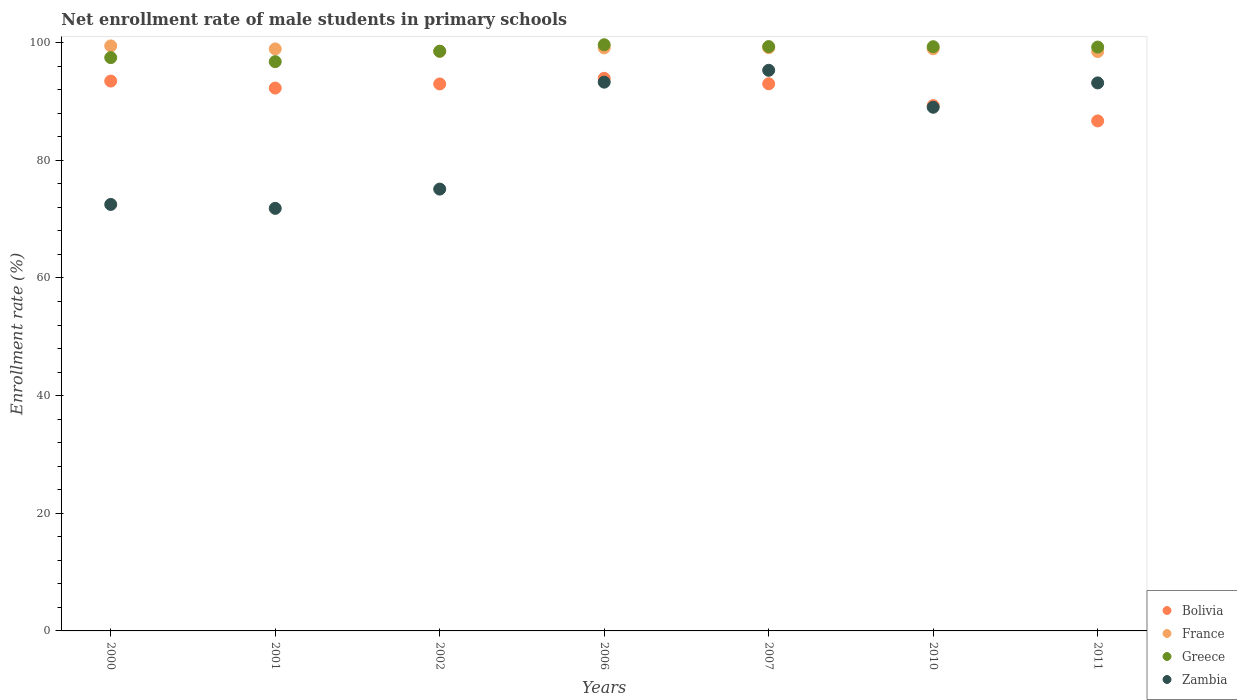How many different coloured dotlines are there?
Make the answer very short. 4. Is the number of dotlines equal to the number of legend labels?
Your response must be concise. Yes. What is the net enrollment rate of male students in primary schools in France in 2006?
Your response must be concise. 99.11. Across all years, what is the maximum net enrollment rate of male students in primary schools in France?
Offer a terse response. 99.45. Across all years, what is the minimum net enrollment rate of male students in primary schools in France?
Your response must be concise. 98.48. In which year was the net enrollment rate of male students in primary schools in Bolivia maximum?
Provide a succinct answer. 2006. What is the total net enrollment rate of male students in primary schools in Zambia in the graph?
Your response must be concise. 590.21. What is the difference between the net enrollment rate of male students in primary schools in Greece in 2000 and that in 2006?
Ensure brevity in your answer.  -2.19. What is the difference between the net enrollment rate of male students in primary schools in Bolivia in 2011 and the net enrollment rate of male students in primary schools in Greece in 2007?
Give a very brief answer. -12.64. What is the average net enrollment rate of male students in primary schools in Bolivia per year?
Your response must be concise. 91.67. In the year 2002, what is the difference between the net enrollment rate of male students in primary schools in Zambia and net enrollment rate of male students in primary schools in Greece?
Your response must be concise. -23.43. What is the ratio of the net enrollment rate of male students in primary schools in France in 2002 to that in 2007?
Offer a very short reply. 0.99. Is the difference between the net enrollment rate of male students in primary schools in Zambia in 2002 and 2006 greater than the difference between the net enrollment rate of male students in primary schools in Greece in 2002 and 2006?
Provide a succinct answer. No. What is the difference between the highest and the second highest net enrollment rate of male students in primary schools in Greece?
Your response must be concise. 0.31. What is the difference between the highest and the lowest net enrollment rate of male students in primary schools in France?
Your answer should be very brief. 0.97. Is the sum of the net enrollment rate of male students in primary schools in Bolivia in 2000 and 2010 greater than the maximum net enrollment rate of male students in primary schools in Greece across all years?
Ensure brevity in your answer.  Yes. Is it the case that in every year, the sum of the net enrollment rate of male students in primary schools in France and net enrollment rate of male students in primary schools in Greece  is greater than the net enrollment rate of male students in primary schools in Bolivia?
Your answer should be very brief. Yes. Does the net enrollment rate of male students in primary schools in France monotonically increase over the years?
Your answer should be compact. No. Is the net enrollment rate of male students in primary schools in France strictly less than the net enrollment rate of male students in primary schools in Zambia over the years?
Your response must be concise. No. How many dotlines are there?
Your answer should be compact. 4. What is the difference between two consecutive major ticks on the Y-axis?
Your answer should be very brief. 20. Are the values on the major ticks of Y-axis written in scientific E-notation?
Your answer should be very brief. No. Does the graph contain any zero values?
Offer a terse response. No. Does the graph contain grids?
Provide a short and direct response. No. Where does the legend appear in the graph?
Offer a terse response. Bottom right. How many legend labels are there?
Make the answer very short. 4. What is the title of the graph?
Offer a terse response. Net enrollment rate of male students in primary schools. Does "Grenada" appear as one of the legend labels in the graph?
Offer a terse response. No. What is the label or title of the Y-axis?
Make the answer very short. Enrollment rate (%). What is the Enrollment rate (%) in Bolivia in 2000?
Offer a very short reply. 93.47. What is the Enrollment rate (%) of France in 2000?
Keep it short and to the point. 99.45. What is the Enrollment rate (%) in Greece in 2000?
Offer a terse response. 97.46. What is the Enrollment rate (%) of Zambia in 2000?
Offer a very short reply. 72.5. What is the Enrollment rate (%) in Bolivia in 2001?
Your answer should be very brief. 92.28. What is the Enrollment rate (%) in France in 2001?
Offer a terse response. 98.94. What is the Enrollment rate (%) in Greece in 2001?
Keep it short and to the point. 96.77. What is the Enrollment rate (%) in Zambia in 2001?
Offer a terse response. 71.83. What is the Enrollment rate (%) in Bolivia in 2002?
Your response must be concise. 92.98. What is the Enrollment rate (%) of France in 2002?
Ensure brevity in your answer.  98.53. What is the Enrollment rate (%) of Greece in 2002?
Provide a short and direct response. 98.54. What is the Enrollment rate (%) in Zambia in 2002?
Your response must be concise. 75.11. What is the Enrollment rate (%) in Bolivia in 2006?
Offer a terse response. 93.94. What is the Enrollment rate (%) in France in 2006?
Keep it short and to the point. 99.11. What is the Enrollment rate (%) in Greece in 2006?
Give a very brief answer. 99.64. What is the Enrollment rate (%) of Zambia in 2006?
Your response must be concise. 93.29. What is the Enrollment rate (%) of Bolivia in 2007?
Offer a very short reply. 93.01. What is the Enrollment rate (%) of France in 2007?
Provide a short and direct response. 99.14. What is the Enrollment rate (%) in Greece in 2007?
Your answer should be compact. 99.33. What is the Enrollment rate (%) in Zambia in 2007?
Your response must be concise. 95.3. What is the Enrollment rate (%) in Bolivia in 2010?
Your answer should be compact. 89.3. What is the Enrollment rate (%) in France in 2010?
Ensure brevity in your answer.  98.96. What is the Enrollment rate (%) of Greece in 2010?
Make the answer very short. 99.31. What is the Enrollment rate (%) of Zambia in 2010?
Offer a very short reply. 89.02. What is the Enrollment rate (%) in Bolivia in 2011?
Keep it short and to the point. 86.7. What is the Enrollment rate (%) of France in 2011?
Make the answer very short. 98.48. What is the Enrollment rate (%) of Greece in 2011?
Make the answer very short. 99.25. What is the Enrollment rate (%) of Zambia in 2011?
Give a very brief answer. 93.16. Across all years, what is the maximum Enrollment rate (%) in Bolivia?
Your answer should be very brief. 93.94. Across all years, what is the maximum Enrollment rate (%) in France?
Your response must be concise. 99.45. Across all years, what is the maximum Enrollment rate (%) of Greece?
Offer a very short reply. 99.64. Across all years, what is the maximum Enrollment rate (%) of Zambia?
Offer a very short reply. 95.3. Across all years, what is the minimum Enrollment rate (%) in Bolivia?
Make the answer very short. 86.7. Across all years, what is the minimum Enrollment rate (%) of France?
Ensure brevity in your answer.  98.48. Across all years, what is the minimum Enrollment rate (%) in Greece?
Your answer should be compact. 96.77. Across all years, what is the minimum Enrollment rate (%) of Zambia?
Keep it short and to the point. 71.83. What is the total Enrollment rate (%) in Bolivia in the graph?
Your response must be concise. 641.67. What is the total Enrollment rate (%) of France in the graph?
Give a very brief answer. 692.61. What is the total Enrollment rate (%) of Greece in the graph?
Give a very brief answer. 690.31. What is the total Enrollment rate (%) in Zambia in the graph?
Provide a short and direct response. 590.21. What is the difference between the Enrollment rate (%) in Bolivia in 2000 and that in 2001?
Your answer should be very brief. 1.19. What is the difference between the Enrollment rate (%) in France in 2000 and that in 2001?
Give a very brief answer. 0.51. What is the difference between the Enrollment rate (%) in Greece in 2000 and that in 2001?
Provide a succinct answer. 0.69. What is the difference between the Enrollment rate (%) of Zambia in 2000 and that in 2001?
Offer a very short reply. 0.67. What is the difference between the Enrollment rate (%) in Bolivia in 2000 and that in 2002?
Ensure brevity in your answer.  0.49. What is the difference between the Enrollment rate (%) of France in 2000 and that in 2002?
Provide a short and direct response. 0.93. What is the difference between the Enrollment rate (%) in Greece in 2000 and that in 2002?
Keep it short and to the point. -1.09. What is the difference between the Enrollment rate (%) of Zambia in 2000 and that in 2002?
Your response must be concise. -2.61. What is the difference between the Enrollment rate (%) of Bolivia in 2000 and that in 2006?
Keep it short and to the point. -0.47. What is the difference between the Enrollment rate (%) in France in 2000 and that in 2006?
Ensure brevity in your answer.  0.34. What is the difference between the Enrollment rate (%) in Greece in 2000 and that in 2006?
Your answer should be compact. -2.19. What is the difference between the Enrollment rate (%) of Zambia in 2000 and that in 2006?
Ensure brevity in your answer.  -20.79. What is the difference between the Enrollment rate (%) of Bolivia in 2000 and that in 2007?
Give a very brief answer. 0.46. What is the difference between the Enrollment rate (%) in France in 2000 and that in 2007?
Your response must be concise. 0.31. What is the difference between the Enrollment rate (%) of Greece in 2000 and that in 2007?
Provide a succinct answer. -1.88. What is the difference between the Enrollment rate (%) in Zambia in 2000 and that in 2007?
Ensure brevity in your answer.  -22.8. What is the difference between the Enrollment rate (%) in Bolivia in 2000 and that in 2010?
Provide a succinct answer. 4.17. What is the difference between the Enrollment rate (%) in France in 2000 and that in 2010?
Provide a short and direct response. 0.5. What is the difference between the Enrollment rate (%) of Greece in 2000 and that in 2010?
Your response must be concise. -1.85. What is the difference between the Enrollment rate (%) in Zambia in 2000 and that in 2010?
Your answer should be compact. -16.52. What is the difference between the Enrollment rate (%) in Bolivia in 2000 and that in 2011?
Make the answer very short. 6.77. What is the difference between the Enrollment rate (%) of France in 2000 and that in 2011?
Make the answer very short. 0.97. What is the difference between the Enrollment rate (%) in Greece in 2000 and that in 2011?
Ensure brevity in your answer.  -1.79. What is the difference between the Enrollment rate (%) in Zambia in 2000 and that in 2011?
Ensure brevity in your answer.  -20.66. What is the difference between the Enrollment rate (%) of Bolivia in 2001 and that in 2002?
Make the answer very short. -0.7. What is the difference between the Enrollment rate (%) in France in 2001 and that in 2002?
Offer a terse response. 0.41. What is the difference between the Enrollment rate (%) of Greece in 2001 and that in 2002?
Your response must be concise. -1.77. What is the difference between the Enrollment rate (%) in Zambia in 2001 and that in 2002?
Your answer should be very brief. -3.28. What is the difference between the Enrollment rate (%) in Bolivia in 2001 and that in 2006?
Give a very brief answer. -1.65. What is the difference between the Enrollment rate (%) of France in 2001 and that in 2006?
Provide a succinct answer. -0.17. What is the difference between the Enrollment rate (%) of Greece in 2001 and that in 2006?
Make the answer very short. -2.87. What is the difference between the Enrollment rate (%) in Zambia in 2001 and that in 2006?
Keep it short and to the point. -21.45. What is the difference between the Enrollment rate (%) in Bolivia in 2001 and that in 2007?
Your answer should be very brief. -0.72. What is the difference between the Enrollment rate (%) of France in 2001 and that in 2007?
Ensure brevity in your answer.  -0.2. What is the difference between the Enrollment rate (%) of Greece in 2001 and that in 2007?
Ensure brevity in your answer.  -2.56. What is the difference between the Enrollment rate (%) in Zambia in 2001 and that in 2007?
Make the answer very short. -23.47. What is the difference between the Enrollment rate (%) of Bolivia in 2001 and that in 2010?
Offer a very short reply. 2.98. What is the difference between the Enrollment rate (%) of France in 2001 and that in 2010?
Your answer should be compact. -0.02. What is the difference between the Enrollment rate (%) in Greece in 2001 and that in 2010?
Your answer should be very brief. -2.54. What is the difference between the Enrollment rate (%) of Zambia in 2001 and that in 2010?
Offer a very short reply. -17.19. What is the difference between the Enrollment rate (%) in Bolivia in 2001 and that in 2011?
Provide a succinct answer. 5.58. What is the difference between the Enrollment rate (%) of France in 2001 and that in 2011?
Your response must be concise. 0.46. What is the difference between the Enrollment rate (%) of Greece in 2001 and that in 2011?
Make the answer very short. -2.48. What is the difference between the Enrollment rate (%) of Zambia in 2001 and that in 2011?
Your answer should be compact. -21.32. What is the difference between the Enrollment rate (%) of Bolivia in 2002 and that in 2006?
Provide a succinct answer. -0.95. What is the difference between the Enrollment rate (%) of France in 2002 and that in 2006?
Provide a short and direct response. -0.58. What is the difference between the Enrollment rate (%) in Greece in 2002 and that in 2006?
Provide a short and direct response. -1.1. What is the difference between the Enrollment rate (%) of Zambia in 2002 and that in 2006?
Ensure brevity in your answer.  -18.18. What is the difference between the Enrollment rate (%) of Bolivia in 2002 and that in 2007?
Keep it short and to the point. -0.02. What is the difference between the Enrollment rate (%) of France in 2002 and that in 2007?
Your answer should be very brief. -0.61. What is the difference between the Enrollment rate (%) in Greece in 2002 and that in 2007?
Offer a terse response. -0.79. What is the difference between the Enrollment rate (%) of Zambia in 2002 and that in 2007?
Your answer should be compact. -20.19. What is the difference between the Enrollment rate (%) of Bolivia in 2002 and that in 2010?
Your response must be concise. 3.68. What is the difference between the Enrollment rate (%) in France in 2002 and that in 2010?
Your answer should be very brief. -0.43. What is the difference between the Enrollment rate (%) of Greece in 2002 and that in 2010?
Your answer should be compact. -0.77. What is the difference between the Enrollment rate (%) of Zambia in 2002 and that in 2010?
Your answer should be compact. -13.91. What is the difference between the Enrollment rate (%) in Bolivia in 2002 and that in 2011?
Give a very brief answer. 6.28. What is the difference between the Enrollment rate (%) of France in 2002 and that in 2011?
Provide a succinct answer. 0.04. What is the difference between the Enrollment rate (%) of Greece in 2002 and that in 2011?
Your response must be concise. -0.71. What is the difference between the Enrollment rate (%) in Zambia in 2002 and that in 2011?
Make the answer very short. -18.05. What is the difference between the Enrollment rate (%) of Bolivia in 2006 and that in 2007?
Your answer should be very brief. 0.93. What is the difference between the Enrollment rate (%) in France in 2006 and that in 2007?
Provide a succinct answer. -0.03. What is the difference between the Enrollment rate (%) of Greece in 2006 and that in 2007?
Give a very brief answer. 0.31. What is the difference between the Enrollment rate (%) in Zambia in 2006 and that in 2007?
Your response must be concise. -2.01. What is the difference between the Enrollment rate (%) of Bolivia in 2006 and that in 2010?
Give a very brief answer. 4.63. What is the difference between the Enrollment rate (%) in France in 2006 and that in 2010?
Ensure brevity in your answer.  0.15. What is the difference between the Enrollment rate (%) of Greece in 2006 and that in 2010?
Provide a succinct answer. 0.33. What is the difference between the Enrollment rate (%) in Zambia in 2006 and that in 2010?
Provide a short and direct response. 4.27. What is the difference between the Enrollment rate (%) in Bolivia in 2006 and that in 2011?
Your answer should be compact. 7.24. What is the difference between the Enrollment rate (%) of France in 2006 and that in 2011?
Offer a terse response. 0.63. What is the difference between the Enrollment rate (%) in Greece in 2006 and that in 2011?
Offer a very short reply. 0.39. What is the difference between the Enrollment rate (%) of Zambia in 2006 and that in 2011?
Provide a short and direct response. 0.13. What is the difference between the Enrollment rate (%) of Bolivia in 2007 and that in 2010?
Provide a short and direct response. 3.7. What is the difference between the Enrollment rate (%) of France in 2007 and that in 2010?
Your response must be concise. 0.18. What is the difference between the Enrollment rate (%) in Greece in 2007 and that in 2010?
Your response must be concise. 0.02. What is the difference between the Enrollment rate (%) of Zambia in 2007 and that in 2010?
Provide a succinct answer. 6.28. What is the difference between the Enrollment rate (%) of Bolivia in 2007 and that in 2011?
Your answer should be compact. 6.31. What is the difference between the Enrollment rate (%) in France in 2007 and that in 2011?
Provide a succinct answer. 0.65. What is the difference between the Enrollment rate (%) in Greece in 2007 and that in 2011?
Ensure brevity in your answer.  0.08. What is the difference between the Enrollment rate (%) of Zambia in 2007 and that in 2011?
Make the answer very short. 2.14. What is the difference between the Enrollment rate (%) of Bolivia in 2010 and that in 2011?
Ensure brevity in your answer.  2.6. What is the difference between the Enrollment rate (%) of France in 2010 and that in 2011?
Offer a very short reply. 0.47. What is the difference between the Enrollment rate (%) of Greece in 2010 and that in 2011?
Make the answer very short. 0.06. What is the difference between the Enrollment rate (%) in Zambia in 2010 and that in 2011?
Your answer should be very brief. -4.14. What is the difference between the Enrollment rate (%) of Bolivia in 2000 and the Enrollment rate (%) of France in 2001?
Provide a succinct answer. -5.47. What is the difference between the Enrollment rate (%) of Bolivia in 2000 and the Enrollment rate (%) of Greece in 2001?
Keep it short and to the point. -3.3. What is the difference between the Enrollment rate (%) of Bolivia in 2000 and the Enrollment rate (%) of Zambia in 2001?
Ensure brevity in your answer.  21.64. What is the difference between the Enrollment rate (%) of France in 2000 and the Enrollment rate (%) of Greece in 2001?
Offer a very short reply. 2.68. What is the difference between the Enrollment rate (%) of France in 2000 and the Enrollment rate (%) of Zambia in 2001?
Your answer should be very brief. 27.62. What is the difference between the Enrollment rate (%) in Greece in 2000 and the Enrollment rate (%) in Zambia in 2001?
Your response must be concise. 25.62. What is the difference between the Enrollment rate (%) in Bolivia in 2000 and the Enrollment rate (%) in France in 2002?
Give a very brief answer. -5.06. What is the difference between the Enrollment rate (%) in Bolivia in 2000 and the Enrollment rate (%) in Greece in 2002?
Your response must be concise. -5.07. What is the difference between the Enrollment rate (%) of Bolivia in 2000 and the Enrollment rate (%) of Zambia in 2002?
Offer a very short reply. 18.36. What is the difference between the Enrollment rate (%) in France in 2000 and the Enrollment rate (%) in Greece in 2002?
Make the answer very short. 0.91. What is the difference between the Enrollment rate (%) of France in 2000 and the Enrollment rate (%) of Zambia in 2002?
Your answer should be compact. 24.34. What is the difference between the Enrollment rate (%) in Greece in 2000 and the Enrollment rate (%) in Zambia in 2002?
Your answer should be compact. 22.35. What is the difference between the Enrollment rate (%) in Bolivia in 2000 and the Enrollment rate (%) in France in 2006?
Provide a succinct answer. -5.64. What is the difference between the Enrollment rate (%) in Bolivia in 2000 and the Enrollment rate (%) in Greece in 2006?
Offer a very short reply. -6.17. What is the difference between the Enrollment rate (%) in Bolivia in 2000 and the Enrollment rate (%) in Zambia in 2006?
Your response must be concise. 0.18. What is the difference between the Enrollment rate (%) of France in 2000 and the Enrollment rate (%) of Greece in 2006?
Give a very brief answer. -0.19. What is the difference between the Enrollment rate (%) of France in 2000 and the Enrollment rate (%) of Zambia in 2006?
Give a very brief answer. 6.17. What is the difference between the Enrollment rate (%) of Greece in 2000 and the Enrollment rate (%) of Zambia in 2006?
Your answer should be compact. 4.17. What is the difference between the Enrollment rate (%) of Bolivia in 2000 and the Enrollment rate (%) of France in 2007?
Your answer should be very brief. -5.67. What is the difference between the Enrollment rate (%) in Bolivia in 2000 and the Enrollment rate (%) in Greece in 2007?
Provide a short and direct response. -5.86. What is the difference between the Enrollment rate (%) in Bolivia in 2000 and the Enrollment rate (%) in Zambia in 2007?
Offer a terse response. -1.83. What is the difference between the Enrollment rate (%) in France in 2000 and the Enrollment rate (%) in Greece in 2007?
Your response must be concise. 0.12. What is the difference between the Enrollment rate (%) of France in 2000 and the Enrollment rate (%) of Zambia in 2007?
Ensure brevity in your answer.  4.15. What is the difference between the Enrollment rate (%) in Greece in 2000 and the Enrollment rate (%) in Zambia in 2007?
Your answer should be compact. 2.15. What is the difference between the Enrollment rate (%) of Bolivia in 2000 and the Enrollment rate (%) of France in 2010?
Your answer should be very brief. -5.49. What is the difference between the Enrollment rate (%) of Bolivia in 2000 and the Enrollment rate (%) of Greece in 2010?
Offer a terse response. -5.84. What is the difference between the Enrollment rate (%) of Bolivia in 2000 and the Enrollment rate (%) of Zambia in 2010?
Your answer should be compact. 4.45. What is the difference between the Enrollment rate (%) in France in 2000 and the Enrollment rate (%) in Greece in 2010?
Offer a terse response. 0.14. What is the difference between the Enrollment rate (%) in France in 2000 and the Enrollment rate (%) in Zambia in 2010?
Ensure brevity in your answer.  10.43. What is the difference between the Enrollment rate (%) in Greece in 2000 and the Enrollment rate (%) in Zambia in 2010?
Your answer should be very brief. 8.44. What is the difference between the Enrollment rate (%) in Bolivia in 2000 and the Enrollment rate (%) in France in 2011?
Give a very brief answer. -5.01. What is the difference between the Enrollment rate (%) in Bolivia in 2000 and the Enrollment rate (%) in Greece in 2011?
Provide a short and direct response. -5.78. What is the difference between the Enrollment rate (%) of Bolivia in 2000 and the Enrollment rate (%) of Zambia in 2011?
Give a very brief answer. 0.31. What is the difference between the Enrollment rate (%) of France in 2000 and the Enrollment rate (%) of Greece in 2011?
Ensure brevity in your answer.  0.2. What is the difference between the Enrollment rate (%) in France in 2000 and the Enrollment rate (%) in Zambia in 2011?
Your answer should be compact. 6.3. What is the difference between the Enrollment rate (%) in Greece in 2000 and the Enrollment rate (%) in Zambia in 2011?
Ensure brevity in your answer.  4.3. What is the difference between the Enrollment rate (%) of Bolivia in 2001 and the Enrollment rate (%) of France in 2002?
Offer a terse response. -6.24. What is the difference between the Enrollment rate (%) in Bolivia in 2001 and the Enrollment rate (%) in Greece in 2002?
Ensure brevity in your answer.  -6.26. What is the difference between the Enrollment rate (%) of Bolivia in 2001 and the Enrollment rate (%) of Zambia in 2002?
Make the answer very short. 17.17. What is the difference between the Enrollment rate (%) in France in 2001 and the Enrollment rate (%) in Greece in 2002?
Provide a short and direct response. 0.4. What is the difference between the Enrollment rate (%) of France in 2001 and the Enrollment rate (%) of Zambia in 2002?
Provide a succinct answer. 23.83. What is the difference between the Enrollment rate (%) of Greece in 2001 and the Enrollment rate (%) of Zambia in 2002?
Your answer should be compact. 21.66. What is the difference between the Enrollment rate (%) in Bolivia in 2001 and the Enrollment rate (%) in France in 2006?
Ensure brevity in your answer.  -6.83. What is the difference between the Enrollment rate (%) of Bolivia in 2001 and the Enrollment rate (%) of Greece in 2006?
Provide a succinct answer. -7.36. What is the difference between the Enrollment rate (%) in Bolivia in 2001 and the Enrollment rate (%) in Zambia in 2006?
Ensure brevity in your answer.  -1. What is the difference between the Enrollment rate (%) in France in 2001 and the Enrollment rate (%) in Greece in 2006?
Offer a terse response. -0.7. What is the difference between the Enrollment rate (%) in France in 2001 and the Enrollment rate (%) in Zambia in 2006?
Provide a short and direct response. 5.65. What is the difference between the Enrollment rate (%) of Greece in 2001 and the Enrollment rate (%) of Zambia in 2006?
Your answer should be very brief. 3.48. What is the difference between the Enrollment rate (%) in Bolivia in 2001 and the Enrollment rate (%) in France in 2007?
Keep it short and to the point. -6.86. What is the difference between the Enrollment rate (%) of Bolivia in 2001 and the Enrollment rate (%) of Greece in 2007?
Your answer should be very brief. -7.05. What is the difference between the Enrollment rate (%) in Bolivia in 2001 and the Enrollment rate (%) in Zambia in 2007?
Your response must be concise. -3.02. What is the difference between the Enrollment rate (%) in France in 2001 and the Enrollment rate (%) in Greece in 2007?
Offer a very short reply. -0.39. What is the difference between the Enrollment rate (%) of France in 2001 and the Enrollment rate (%) of Zambia in 2007?
Keep it short and to the point. 3.64. What is the difference between the Enrollment rate (%) in Greece in 2001 and the Enrollment rate (%) in Zambia in 2007?
Give a very brief answer. 1.47. What is the difference between the Enrollment rate (%) in Bolivia in 2001 and the Enrollment rate (%) in France in 2010?
Your response must be concise. -6.67. What is the difference between the Enrollment rate (%) of Bolivia in 2001 and the Enrollment rate (%) of Greece in 2010?
Provide a short and direct response. -7.03. What is the difference between the Enrollment rate (%) of Bolivia in 2001 and the Enrollment rate (%) of Zambia in 2010?
Offer a very short reply. 3.26. What is the difference between the Enrollment rate (%) of France in 2001 and the Enrollment rate (%) of Greece in 2010?
Provide a short and direct response. -0.37. What is the difference between the Enrollment rate (%) in France in 2001 and the Enrollment rate (%) in Zambia in 2010?
Your response must be concise. 9.92. What is the difference between the Enrollment rate (%) of Greece in 2001 and the Enrollment rate (%) of Zambia in 2010?
Provide a succinct answer. 7.75. What is the difference between the Enrollment rate (%) of Bolivia in 2001 and the Enrollment rate (%) of France in 2011?
Your response must be concise. -6.2. What is the difference between the Enrollment rate (%) of Bolivia in 2001 and the Enrollment rate (%) of Greece in 2011?
Provide a succinct answer. -6.97. What is the difference between the Enrollment rate (%) of Bolivia in 2001 and the Enrollment rate (%) of Zambia in 2011?
Keep it short and to the point. -0.87. What is the difference between the Enrollment rate (%) in France in 2001 and the Enrollment rate (%) in Greece in 2011?
Provide a succinct answer. -0.31. What is the difference between the Enrollment rate (%) in France in 2001 and the Enrollment rate (%) in Zambia in 2011?
Make the answer very short. 5.78. What is the difference between the Enrollment rate (%) of Greece in 2001 and the Enrollment rate (%) of Zambia in 2011?
Ensure brevity in your answer.  3.61. What is the difference between the Enrollment rate (%) in Bolivia in 2002 and the Enrollment rate (%) in France in 2006?
Make the answer very short. -6.13. What is the difference between the Enrollment rate (%) in Bolivia in 2002 and the Enrollment rate (%) in Greece in 2006?
Make the answer very short. -6.66. What is the difference between the Enrollment rate (%) in Bolivia in 2002 and the Enrollment rate (%) in Zambia in 2006?
Keep it short and to the point. -0.31. What is the difference between the Enrollment rate (%) of France in 2002 and the Enrollment rate (%) of Greece in 2006?
Offer a terse response. -1.12. What is the difference between the Enrollment rate (%) of France in 2002 and the Enrollment rate (%) of Zambia in 2006?
Provide a succinct answer. 5.24. What is the difference between the Enrollment rate (%) in Greece in 2002 and the Enrollment rate (%) in Zambia in 2006?
Make the answer very short. 5.26. What is the difference between the Enrollment rate (%) in Bolivia in 2002 and the Enrollment rate (%) in France in 2007?
Keep it short and to the point. -6.16. What is the difference between the Enrollment rate (%) in Bolivia in 2002 and the Enrollment rate (%) in Greece in 2007?
Keep it short and to the point. -6.35. What is the difference between the Enrollment rate (%) in Bolivia in 2002 and the Enrollment rate (%) in Zambia in 2007?
Offer a very short reply. -2.32. What is the difference between the Enrollment rate (%) in France in 2002 and the Enrollment rate (%) in Greece in 2007?
Provide a succinct answer. -0.81. What is the difference between the Enrollment rate (%) in France in 2002 and the Enrollment rate (%) in Zambia in 2007?
Ensure brevity in your answer.  3.22. What is the difference between the Enrollment rate (%) in Greece in 2002 and the Enrollment rate (%) in Zambia in 2007?
Keep it short and to the point. 3.24. What is the difference between the Enrollment rate (%) in Bolivia in 2002 and the Enrollment rate (%) in France in 2010?
Provide a succinct answer. -5.98. What is the difference between the Enrollment rate (%) of Bolivia in 2002 and the Enrollment rate (%) of Greece in 2010?
Offer a very short reply. -6.33. What is the difference between the Enrollment rate (%) of Bolivia in 2002 and the Enrollment rate (%) of Zambia in 2010?
Offer a very short reply. 3.96. What is the difference between the Enrollment rate (%) of France in 2002 and the Enrollment rate (%) of Greece in 2010?
Your answer should be very brief. -0.79. What is the difference between the Enrollment rate (%) in France in 2002 and the Enrollment rate (%) in Zambia in 2010?
Offer a very short reply. 9.51. What is the difference between the Enrollment rate (%) in Greece in 2002 and the Enrollment rate (%) in Zambia in 2010?
Offer a very short reply. 9.52. What is the difference between the Enrollment rate (%) of Bolivia in 2002 and the Enrollment rate (%) of France in 2011?
Keep it short and to the point. -5.5. What is the difference between the Enrollment rate (%) in Bolivia in 2002 and the Enrollment rate (%) in Greece in 2011?
Offer a very short reply. -6.27. What is the difference between the Enrollment rate (%) of Bolivia in 2002 and the Enrollment rate (%) of Zambia in 2011?
Your response must be concise. -0.18. What is the difference between the Enrollment rate (%) in France in 2002 and the Enrollment rate (%) in Greece in 2011?
Make the answer very short. -0.72. What is the difference between the Enrollment rate (%) in France in 2002 and the Enrollment rate (%) in Zambia in 2011?
Your answer should be very brief. 5.37. What is the difference between the Enrollment rate (%) in Greece in 2002 and the Enrollment rate (%) in Zambia in 2011?
Ensure brevity in your answer.  5.38. What is the difference between the Enrollment rate (%) of Bolivia in 2006 and the Enrollment rate (%) of France in 2007?
Your answer should be very brief. -5.2. What is the difference between the Enrollment rate (%) of Bolivia in 2006 and the Enrollment rate (%) of Greece in 2007?
Provide a succinct answer. -5.4. What is the difference between the Enrollment rate (%) in Bolivia in 2006 and the Enrollment rate (%) in Zambia in 2007?
Offer a terse response. -1.37. What is the difference between the Enrollment rate (%) of France in 2006 and the Enrollment rate (%) of Greece in 2007?
Your response must be concise. -0.23. What is the difference between the Enrollment rate (%) in France in 2006 and the Enrollment rate (%) in Zambia in 2007?
Make the answer very short. 3.81. What is the difference between the Enrollment rate (%) of Greece in 2006 and the Enrollment rate (%) of Zambia in 2007?
Offer a very short reply. 4.34. What is the difference between the Enrollment rate (%) of Bolivia in 2006 and the Enrollment rate (%) of France in 2010?
Offer a terse response. -5.02. What is the difference between the Enrollment rate (%) of Bolivia in 2006 and the Enrollment rate (%) of Greece in 2010?
Offer a very short reply. -5.38. What is the difference between the Enrollment rate (%) in Bolivia in 2006 and the Enrollment rate (%) in Zambia in 2010?
Offer a very short reply. 4.92. What is the difference between the Enrollment rate (%) of France in 2006 and the Enrollment rate (%) of Greece in 2010?
Your answer should be very brief. -0.2. What is the difference between the Enrollment rate (%) in France in 2006 and the Enrollment rate (%) in Zambia in 2010?
Ensure brevity in your answer.  10.09. What is the difference between the Enrollment rate (%) in Greece in 2006 and the Enrollment rate (%) in Zambia in 2010?
Offer a terse response. 10.63. What is the difference between the Enrollment rate (%) in Bolivia in 2006 and the Enrollment rate (%) in France in 2011?
Your response must be concise. -4.55. What is the difference between the Enrollment rate (%) in Bolivia in 2006 and the Enrollment rate (%) in Greece in 2011?
Your response must be concise. -5.31. What is the difference between the Enrollment rate (%) of Bolivia in 2006 and the Enrollment rate (%) of Zambia in 2011?
Offer a terse response. 0.78. What is the difference between the Enrollment rate (%) in France in 2006 and the Enrollment rate (%) in Greece in 2011?
Your answer should be very brief. -0.14. What is the difference between the Enrollment rate (%) of France in 2006 and the Enrollment rate (%) of Zambia in 2011?
Provide a short and direct response. 5.95. What is the difference between the Enrollment rate (%) of Greece in 2006 and the Enrollment rate (%) of Zambia in 2011?
Make the answer very short. 6.49. What is the difference between the Enrollment rate (%) in Bolivia in 2007 and the Enrollment rate (%) in France in 2010?
Your response must be concise. -5.95. What is the difference between the Enrollment rate (%) in Bolivia in 2007 and the Enrollment rate (%) in Greece in 2010?
Offer a very short reply. -6.31. What is the difference between the Enrollment rate (%) of Bolivia in 2007 and the Enrollment rate (%) of Zambia in 2010?
Ensure brevity in your answer.  3.99. What is the difference between the Enrollment rate (%) in France in 2007 and the Enrollment rate (%) in Greece in 2010?
Give a very brief answer. -0.17. What is the difference between the Enrollment rate (%) in France in 2007 and the Enrollment rate (%) in Zambia in 2010?
Your response must be concise. 10.12. What is the difference between the Enrollment rate (%) of Greece in 2007 and the Enrollment rate (%) of Zambia in 2010?
Offer a terse response. 10.32. What is the difference between the Enrollment rate (%) of Bolivia in 2007 and the Enrollment rate (%) of France in 2011?
Your answer should be very brief. -5.48. What is the difference between the Enrollment rate (%) in Bolivia in 2007 and the Enrollment rate (%) in Greece in 2011?
Make the answer very short. -6.24. What is the difference between the Enrollment rate (%) of Bolivia in 2007 and the Enrollment rate (%) of Zambia in 2011?
Ensure brevity in your answer.  -0.15. What is the difference between the Enrollment rate (%) of France in 2007 and the Enrollment rate (%) of Greece in 2011?
Provide a succinct answer. -0.11. What is the difference between the Enrollment rate (%) of France in 2007 and the Enrollment rate (%) of Zambia in 2011?
Offer a very short reply. 5.98. What is the difference between the Enrollment rate (%) in Greece in 2007 and the Enrollment rate (%) in Zambia in 2011?
Your answer should be very brief. 6.18. What is the difference between the Enrollment rate (%) in Bolivia in 2010 and the Enrollment rate (%) in France in 2011?
Your answer should be compact. -9.18. What is the difference between the Enrollment rate (%) of Bolivia in 2010 and the Enrollment rate (%) of Greece in 2011?
Offer a very short reply. -9.95. What is the difference between the Enrollment rate (%) in Bolivia in 2010 and the Enrollment rate (%) in Zambia in 2011?
Provide a succinct answer. -3.86. What is the difference between the Enrollment rate (%) of France in 2010 and the Enrollment rate (%) of Greece in 2011?
Ensure brevity in your answer.  -0.29. What is the difference between the Enrollment rate (%) in France in 2010 and the Enrollment rate (%) in Zambia in 2011?
Your answer should be compact. 5.8. What is the difference between the Enrollment rate (%) of Greece in 2010 and the Enrollment rate (%) of Zambia in 2011?
Offer a terse response. 6.15. What is the average Enrollment rate (%) of Bolivia per year?
Ensure brevity in your answer.  91.67. What is the average Enrollment rate (%) of France per year?
Provide a short and direct response. 98.94. What is the average Enrollment rate (%) in Greece per year?
Provide a succinct answer. 98.62. What is the average Enrollment rate (%) in Zambia per year?
Offer a terse response. 84.32. In the year 2000, what is the difference between the Enrollment rate (%) in Bolivia and Enrollment rate (%) in France?
Your answer should be compact. -5.98. In the year 2000, what is the difference between the Enrollment rate (%) of Bolivia and Enrollment rate (%) of Greece?
Your answer should be compact. -3.99. In the year 2000, what is the difference between the Enrollment rate (%) in Bolivia and Enrollment rate (%) in Zambia?
Give a very brief answer. 20.97. In the year 2000, what is the difference between the Enrollment rate (%) of France and Enrollment rate (%) of Greece?
Your response must be concise. 2. In the year 2000, what is the difference between the Enrollment rate (%) of France and Enrollment rate (%) of Zambia?
Give a very brief answer. 26.95. In the year 2000, what is the difference between the Enrollment rate (%) of Greece and Enrollment rate (%) of Zambia?
Ensure brevity in your answer.  24.96. In the year 2001, what is the difference between the Enrollment rate (%) of Bolivia and Enrollment rate (%) of France?
Give a very brief answer. -6.66. In the year 2001, what is the difference between the Enrollment rate (%) in Bolivia and Enrollment rate (%) in Greece?
Ensure brevity in your answer.  -4.49. In the year 2001, what is the difference between the Enrollment rate (%) of Bolivia and Enrollment rate (%) of Zambia?
Your answer should be compact. 20.45. In the year 2001, what is the difference between the Enrollment rate (%) in France and Enrollment rate (%) in Greece?
Make the answer very short. 2.17. In the year 2001, what is the difference between the Enrollment rate (%) of France and Enrollment rate (%) of Zambia?
Make the answer very short. 27.11. In the year 2001, what is the difference between the Enrollment rate (%) in Greece and Enrollment rate (%) in Zambia?
Your answer should be compact. 24.94. In the year 2002, what is the difference between the Enrollment rate (%) of Bolivia and Enrollment rate (%) of France?
Your response must be concise. -5.54. In the year 2002, what is the difference between the Enrollment rate (%) in Bolivia and Enrollment rate (%) in Greece?
Provide a short and direct response. -5.56. In the year 2002, what is the difference between the Enrollment rate (%) in Bolivia and Enrollment rate (%) in Zambia?
Make the answer very short. 17.87. In the year 2002, what is the difference between the Enrollment rate (%) in France and Enrollment rate (%) in Greece?
Give a very brief answer. -0.02. In the year 2002, what is the difference between the Enrollment rate (%) of France and Enrollment rate (%) of Zambia?
Provide a short and direct response. 23.42. In the year 2002, what is the difference between the Enrollment rate (%) in Greece and Enrollment rate (%) in Zambia?
Keep it short and to the point. 23.43. In the year 2006, what is the difference between the Enrollment rate (%) in Bolivia and Enrollment rate (%) in France?
Ensure brevity in your answer.  -5.17. In the year 2006, what is the difference between the Enrollment rate (%) of Bolivia and Enrollment rate (%) of Greece?
Offer a terse response. -5.71. In the year 2006, what is the difference between the Enrollment rate (%) in Bolivia and Enrollment rate (%) in Zambia?
Give a very brief answer. 0.65. In the year 2006, what is the difference between the Enrollment rate (%) of France and Enrollment rate (%) of Greece?
Give a very brief answer. -0.54. In the year 2006, what is the difference between the Enrollment rate (%) of France and Enrollment rate (%) of Zambia?
Ensure brevity in your answer.  5.82. In the year 2006, what is the difference between the Enrollment rate (%) in Greece and Enrollment rate (%) in Zambia?
Make the answer very short. 6.36. In the year 2007, what is the difference between the Enrollment rate (%) in Bolivia and Enrollment rate (%) in France?
Keep it short and to the point. -6.13. In the year 2007, what is the difference between the Enrollment rate (%) of Bolivia and Enrollment rate (%) of Greece?
Keep it short and to the point. -6.33. In the year 2007, what is the difference between the Enrollment rate (%) of Bolivia and Enrollment rate (%) of Zambia?
Make the answer very short. -2.3. In the year 2007, what is the difference between the Enrollment rate (%) of France and Enrollment rate (%) of Greece?
Your answer should be very brief. -0.2. In the year 2007, what is the difference between the Enrollment rate (%) in France and Enrollment rate (%) in Zambia?
Your response must be concise. 3.84. In the year 2007, what is the difference between the Enrollment rate (%) in Greece and Enrollment rate (%) in Zambia?
Your answer should be compact. 4.03. In the year 2010, what is the difference between the Enrollment rate (%) of Bolivia and Enrollment rate (%) of France?
Provide a short and direct response. -9.66. In the year 2010, what is the difference between the Enrollment rate (%) of Bolivia and Enrollment rate (%) of Greece?
Offer a very short reply. -10.01. In the year 2010, what is the difference between the Enrollment rate (%) of Bolivia and Enrollment rate (%) of Zambia?
Your answer should be compact. 0.28. In the year 2010, what is the difference between the Enrollment rate (%) of France and Enrollment rate (%) of Greece?
Provide a short and direct response. -0.35. In the year 2010, what is the difference between the Enrollment rate (%) in France and Enrollment rate (%) in Zambia?
Ensure brevity in your answer.  9.94. In the year 2010, what is the difference between the Enrollment rate (%) in Greece and Enrollment rate (%) in Zambia?
Offer a terse response. 10.29. In the year 2011, what is the difference between the Enrollment rate (%) of Bolivia and Enrollment rate (%) of France?
Ensure brevity in your answer.  -11.79. In the year 2011, what is the difference between the Enrollment rate (%) of Bolivia and Enrollment rate (%) of Greece?
Your answer should be compact. -12.55. In the year 2011, what is the difference between the Enrollment rate (%) in Bolivia and Enrollment rate (%) in Zambia?
Your response must be concise. -6.46. In the year 2011, what is the difference between the Enrollment rate (%) in France and Enrollment rate (%) in Greece?
Provide a short and direct response. -0.77. In the year 2011, what is the difference between the Enrollment rate (%) in France and Enrollment rate (%) in Zambia?
Your response must be concise. 5.33. In the year 2011, what is the difference between the Enrollment rate (%) in Greece and Enrollment rate (%) in Zambia?
Ensure brevity in your answer.  6.09. What is the ratio of the Enrollment rate (%) in Bolivia in 2000 to that in 2001?
Ensure brevity in your answer.  1.01. What is the ratio of the Enrollment rate (%) in Greece in 2000 to that in 2001?
Offer a very short reply. 1.01. What is the ratio of the Enrollment rate (%) of Zambia in 2000 to that in 2001?
Ensure brevity in your answer.  1.01. What is the ratio of the Enrollment rate (%) in Bolivia in 2000 to that in 2002?
Provide a short and direct response. 1.01. What is the ratio of the Enrollment rate (%) in France in 2000 to that in 2002?
Make the answer very short. 1.01. What is the ratio of the Enrollment rate (%) in Zambia in 2000 to that in 2002?
Give a very brief answer. 0.97. What is the ratio of the Enrollment rate (%) of Greece in 2000 to that in 2006?
Offer a very short reply. 0.98. What is the ratio of the Enrollment rate (%) of Zambia in 2000 to that in 2006?
Offer a very short reply. 0.78. What is the ratio of the Enrollment rate (%) in Greece in 2000 to that in 2007?
Give a very brief answer. 0.98. What is the ratio of the Enrollment rate (%) of Zambia in 2000 to that in 2007?
Keep it short and to the point. 0.76. What is the ratio of the Enrollment rate (%) in Bolivia in 2000 to that in 2010?
Provide a short and direct response. 1.05. What is the ratio of the Enrollment rate (%) in France in 2000 to that in 2010?
Offer a very short reply. 1. What is the ratio of the Enrollment rate (%) of Greece in 2000 to that in 2010?
Offer a very short reply. 0.98. What is the ratio of the Enrollment rate (%) of Zambia in 2000 to that in 2010?
Your response must be concise. 0.81. What is the ratio of the Enrollment rate (%) in Bolivia in 2000 to that in 2011?
Your answer should be very brief. 1.08. What is the ratio of the Enrollment rate (%) of France in 2000 to that in 2011?
Your answer should be compact. 1.01. What is the ratio of the Enrollment rate (%) of Greece in 2000 to that in 2011?
Provide a succinct answer. 0.98. What is the ratio of the Enrollment rate (%) of Zambia in 2000 to that in 2011?
Give a very brief answer. 0.78. What is the ratio of the Enrollment rate (%) in Bolivia in 2001 to that in 2002?
Provide a short and direct response. 0.99. What is the ratio of the Enrollment rate (%) in Greece in 2001 to that in 2002?
Provide a succinct answer. 0.98. What is the ratio of the Enrollment rate (%) in Zambia in 2001 to that in 2002?
Offer a terse response. 0.96. What is the ratio of the Enrollment rate (%) of Bolivia in 2001 to that in 2006?
Provide a short and direct response. 0.98. What is the ratio of the Enrollment rate (%) of Greece in 2001 to that in 2006?
Your answer should be compact. 0.97. What is the ratio of the Enrollment rate (%) in Zambia in 2001 to that in 2006?
Ensure brevity in your answer.  0.77. What is the ratio of the Enrollment rate (%) in France in 2001 to that in 2007?
Make the answer very short. 1. What is the ratio of the Enrollment rate (%) in Greece in 2001 to that in 2007?
Offer a very short reply. 0.97. What is the ratio of the Enrollment rate (%) in Zambia in 2001 to that in 2007?
Keep it short and to the point. 0.75. What is the ratio of the Enrollment rate (%) in Bolivia in 2001 to that in 2010?
Offer a very short reply. 1.03. What is the ratio of the Enrollment rate (%) of Greece in 2001 to that in 2010?
Your response must be concise. 0.97. What is the ratio of the Enrollment rate (%) in Zambia in 2001 to that in 2010?
Your response must be concise. 0.81. What is the ratio of the Enrollment rate (%) of Bolivia in 2001 to that in 2011?
Give a very brief answer. 1.06. What is the ratio of the Enrollment rate (%) in France in 2001 to that in 2011?
Give a very brief answer. 1. What is the ratio of the Enrollment rate (%) of Greece in 2001 to that in 2011?
Keep it short and to the point. 0.97. What is the ratio of the Enrollment rate (%) in Zambia in 2001 to that in 2011?
Give a very brief answer. 0.77. What is the ratio of the Enrollment rate (%) in Bolivia in 2002 to that in 2006?
Your answer should be compact. 0.99. What is the ratio of the Enrollment rate (%) in Greece in 2002 to that in 2006?
Keep it short and to the point. 0.99. What is the ratio of the Enrollment rate (%) of Zambia in 2002 to that in 2006?
Provide a short and direct response. 0.81. What is the ratio of the Enrollment rate (%) in Zambia in 2002 to that in 2007?
Give a very brief answer. 0.79. What is the ratio of the Enrollment rate (%) of Bolivia in 2002 to that in 2010?
Give a very brief answer. 1.04. What is the ratio of the Enrollment rate (%) in Greece in 2002 to that in 2010?
Your answer should be compact. 0.99. What is the ratio of the Enrollment rate (%) in Zambia in 2002 to that in 2010?
Offer a very short reply. 0.84. What is the ratio of the Enrollment rate (%) in Bolivia in 2002 to that in 2011?
Make the answer very short. 1.07. What is the ratio of the Enrollment rate (%) in France in 2002 to that in 2011?
Ensure brevity in your answer.  1. What is the ratio of the Enrollment rate (%) of Zambia in 2002 to that in 2011?
Offer a terse response. 0.81. What is the ratio of the Enrollment rate (%) in France in 2006 to that in 2007?
Provide a succinct answer. 1. What is the ratio of the Enrollment rate (%) of Greece in 2006 to that in 2007?
Keep it short and to the point. 1. What is the ratio of the Enrollment rate (%) of Zambia in 2006 to that in 2007?
Ensure brevity in your answer.  0.98. What is the ratio of the Enrollment rate (%) of Bolivia in 2006 to that in 2010?
Give a very brief answer. 1.05. What is the ratio of the Enrollment rate (%) in France in 2006 to that in 2010?
Offer a very short reply. 1. What is the ratio of the Enrollment rate (%) of Zambia in 2006 to that in 2010?
Ensure brevity in your answer.  1.05. What is the ratio of the Enrollment rate (%) of Bolivia in 2006 to that in 2011?
Make the answer very short. 1.08. What is the ratio of the Enrollment rate (%) of Greece in 2006 to that in 2011?
Offer a terse response. 1. What is the ratio of the Enrollment rate (%) in Bolivia in 2007 to that in 2010?
Your answer should be very brief. 1.04. What is the ratio of the Enrollment rate (%) of France in 2007 to that in 2010?
Your answer should be very brief. 1. What is the ratio of the Enrollment rate (%) of Greece in 2007 to that in 2010?
Offer a very short reply. 1. What is the ratio of the Enrollment rate (%) in Zambia in 2007 to that in 2010?
Keep it short and to the point. 1.07. What is the ratio of the Enrollment rate (%) in Bolivia in 2007 to that in 2011?
Ensure brevity in your answer.  1.07. What is the ratio of the Enrollment rate (%) of France in 2007 to that in 2011?
Give a very brief answer. 1.01. What is the ratio of the Enrollment rate (%) in Greece in 2007 to that in 2011?
Offer a terse response. 1. What is the ratio of the Enrollment rate (%) in Bolivia in 2010 to that in 2011?
Give a very brief answer. 1.03. What is the ratio of the Enrollment rate (%) in France in 2010 to that in 2011?
Your response must be concise. 1. What is the ratio of the Enrollment rate (%) in Zambia in 2010 to that in 2011?
Your response must be concise. 0.96. What is the difference between the highest and the second highest Enrollment rate (%) in Bolivia?
Your answer should be very brief. 0.47. What is the difference between the highest and the second highest Enrollment rate (%) of France?
Provide a short and direct response. 0.31. What is the difference between the highest and the second highest Enrollment rate (%) in Greece?
Give a very brief answer. 0.31. What is the difference between the highest and the second highest Enrollment rate (%) of Zambia?
Give a very brief answer. 2.01. What is the difference between the highest and the lowest Enrollment rate (%) of Bolivia?
Provide a succinct answer. 7.24. What is the difference between the highest and the lowest Enrollment rate (%) of France?
Make the answer very short. 0.97. What is the difference between the highest and the lowest Enrollment rate (%) of Greece?
Provide a succinct answer. 2.87. What is the difference between the highest and the lowest Enrollment rate (%) of Zambia?
Provide a succinct answer. 23.47. 